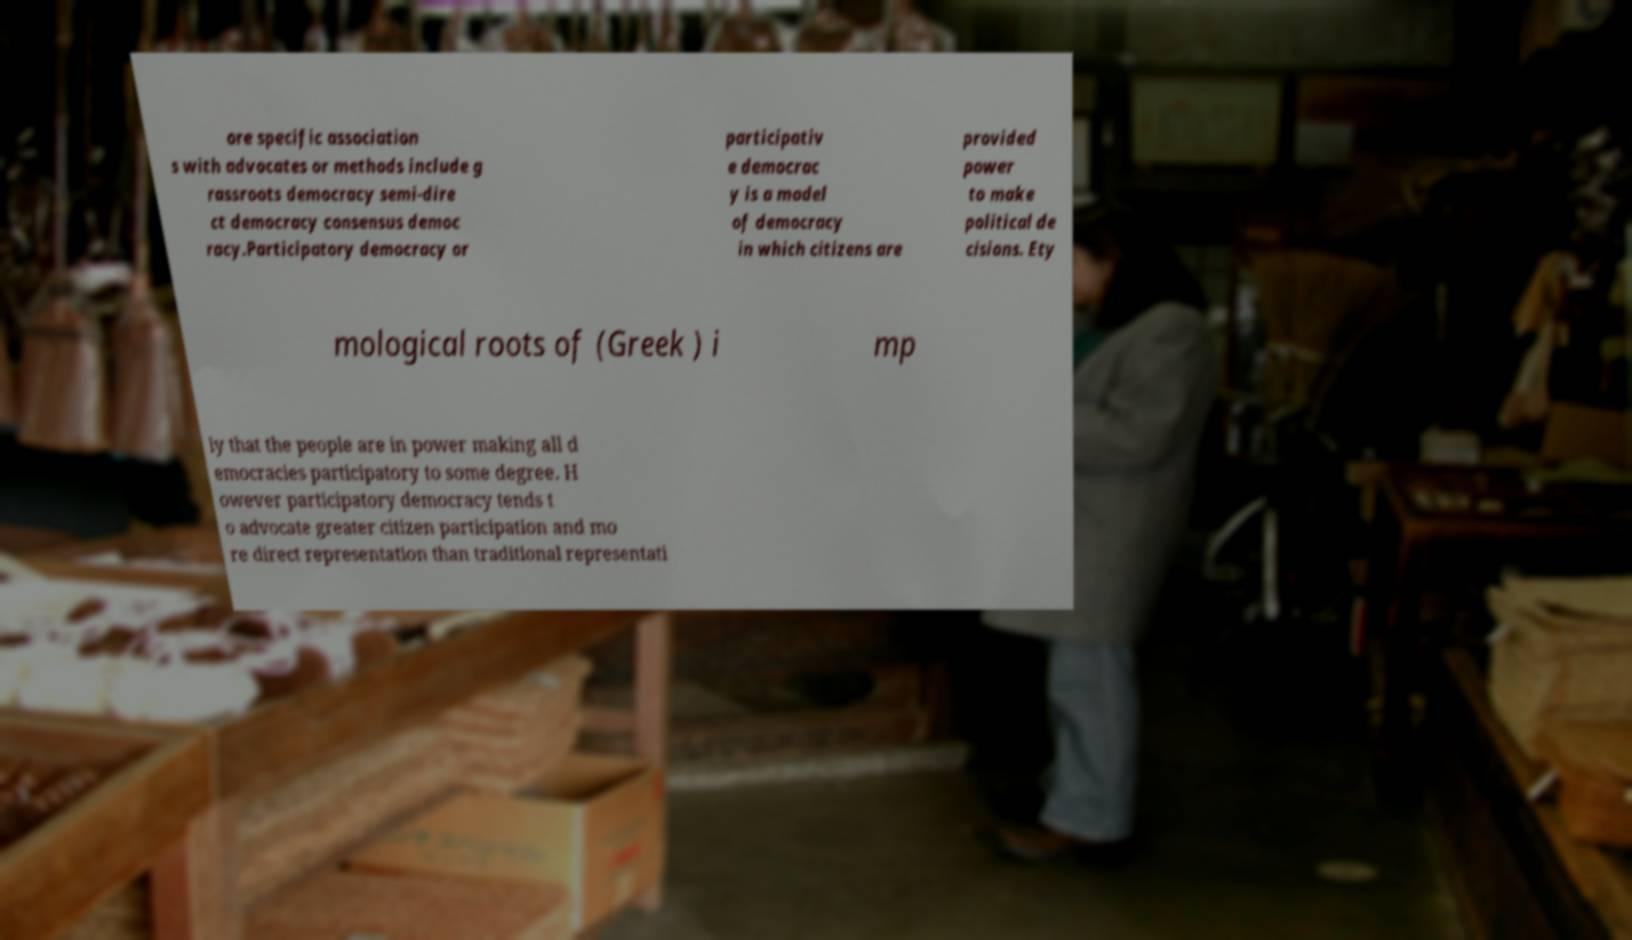Could you assist in decoding the text presented in this image and type it out clearly? ore specific association s with advocates or methods include g rassroots democracy semi-dire ct democracy consensus democ racy.Participatory democracy or participativ e democrac y is a model of democracy in which citizens are provided power to make political de cisions. Ety mological roots of (Greek ) i mp ly that the people are in power making all d emocracies participatory to some degree. H owever participatory democracy tends t o advocate greater citizen participation and mo re direct representation than traditional representati 